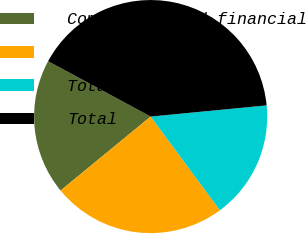Convert chart. <chart><loc_0><loc_0><loc_500><loc_500><pie_chart><fcel>Commercial and financial<fcel>Total US<fcel>Total non-US<fcel>Total<nl><fcel>18.83%<fcel>24.18%<fcel>16.41%<fcel>40.59%<nl></chart> 